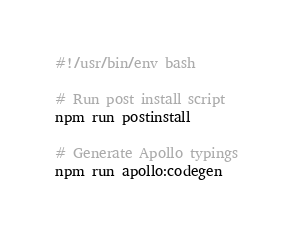Convert code to text. <code><loc_0><loc_0><loc_500><loc_500><_Bash_>#!/usr/bin/env bash

# Run post install script
npm run postinstall

# Generate Apollo typings
npm run apollo:codegen
</code> 